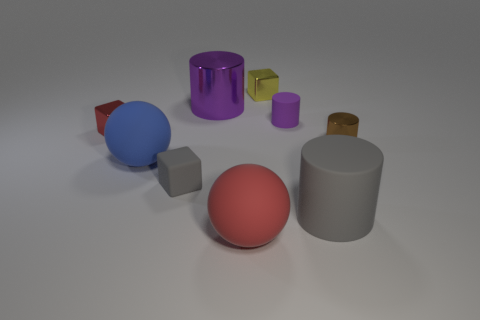What number of yellow things are matte objects or small cubes?
Give a very brief answer. 1. What is the material of the tiny cube that is in front of the big blue thing?
Offer a terse response. Rubber. Are the gray thing that is to the left of the yellow thing and the big blue object made of the same material?
Offer a very short reply. Yes. What is the shape of the small brown object?
Give a very brief answer. Cylinder. There is a tiny metal thing that is behind the big purple shiny cylinder left of the purple rubber object; what number of small rubber objects are in front of it?
Give a very brief answer. 2. How many other things are made of the same material as the big blue object?
Your response must be concise. 4. What is the material of the gray cube that is the same size as the red metal cube?
Offer a terse response. Rubber. There is a large cylinder that is behind the small red shiny block; is its color the same as the large matte thing that is to the left of the small rubber block?
Your answer should be compact. No. Are there any big brown rubber objects of the same shape as the tiny purple matte thing?
Provide a short and direct response. No. The red metallic object that is the same size as the purple matte cylinder is what shape?
Your answer should be very brief. Cube. 